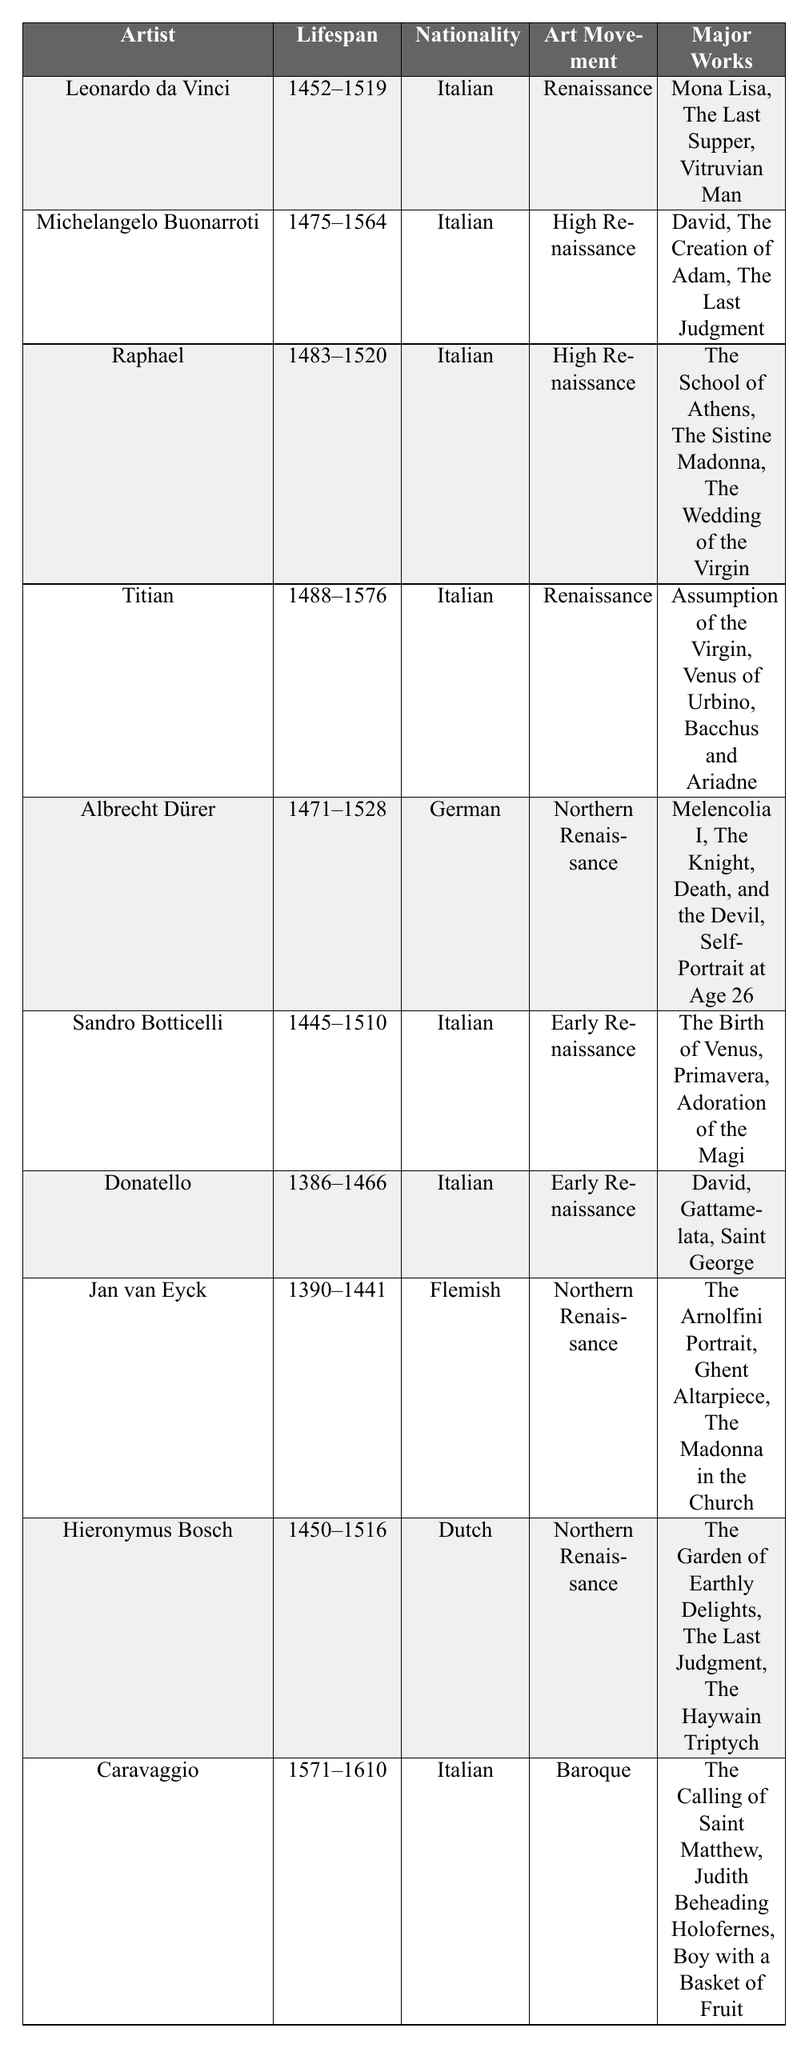What is the nationality of Michelangelo Buonarroti? The table shows that the nationality of Michelangelo Buonarroti is listed directly under the "Nationality" column, which states "Italian".
Answer: Italian How many major works did Leonardo da Vinci create according to the table? The table lists three major works for Leonardo da Vinci: "Mona Lisa," "The Last Supper," and "Vitruvian Man," which can be counted easily.
Answer: 3 Which artist has the longest lifespan among those listed? By calculating the lifespan for each artist, Leonardo da Vinci (1452-1519) lived 67 years, Michelangelo (1475-1564) lived 89 years, and so on. Michelangelo's 89 years is the longest lifespan.
Answer: Michelangelo Buonarroti Is Titian part of the High Renaissance art movement? The table shows that Titian is categorized under the "Renaissance" movement, not "High Renaissance", which renders the statement false.
Answer: No What is the average lifespan of the artists listed in the table? The lifespans of the artists can be calculated as follows: 67 (Leonardo) + 89 (Michelangelo) + 37 (Raphael) + 88 (Titian) + 57 (Dürer) + 65 (Botticelli) + 80 (Donatello) + 51 (Jan van Eyck) + 66 (Bosch) + 39 (Caravaggio) =  1071 years. Then, dividing by 10 artists yields an average lifespan of 107.1 years.
Answer: 107.1 How many artists listed were associated with the High Renaissance art movement? The table identifies Michelangelo and Raphael as being part of the High Renaissance, totaling two artists associated with this movement.
Answer: 2 Which artist created "The Garden of Earthly Delights"? Referring to the "Major Works" column under Hieronymus Bosch, we can see that "The Garden of Earthly Delights" is included as one of his major works.
Answer: Hieronymus Bosch Was Donatello involved in the Northern Renaissance art movement? The table specifies that Donatello is categorized under the "Early Renaissance" movement, indicating that he was not involved in the Northern Renaissance.
Answer: No Which two artists have the same major work titled "David"? The table lists "David" as a major work for both Donatello and Michelangelo, indicating that they share this work.
Answer: Donatello and Michelangelo What are the major works of Albrecht Dürer? Under the "Major Works" column for Albrecht Dürer, three works are listed: "Melencolia I," "The Knight, Death, and the Devil," and "Self-Portrait at Age 26".
Answer: Melencolia I, The Knight, Death, and the Devil, Self-Portrait at Age 26 Which artist is the only one from the Netherlands according to the table? The table shows that Jan van Eyck, listed as having a nationality of "Flemish," is the only artist from the Netherlands in the provided data.
Answer: Jan van Eyck 